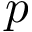Convert formula to latex. <formula><loc_0><loc_0><loc_500><loc_500>p</formula> 